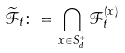Convert formula to latex. <formula><loc_0><loc_0><loc_500><loc_500>\mathcal { \widetilde { F } } _ { t } \colon = \bigcap _ { x \in S _ { d } ^ { + } } \mathcal { F } ^ { ( x ) } _ { t }</formula> 